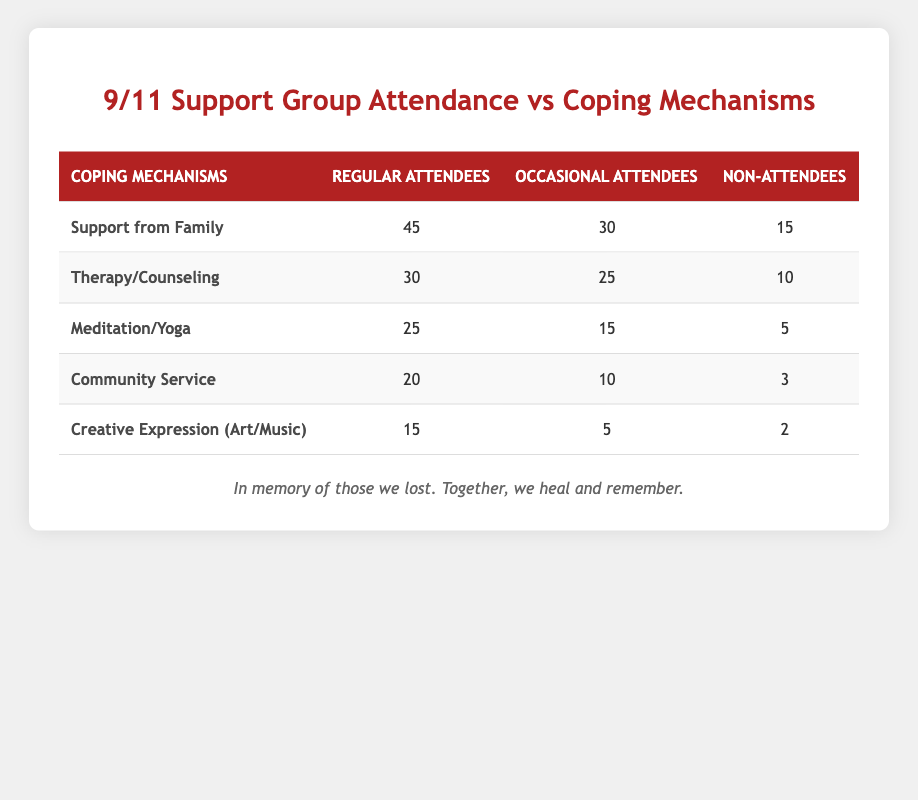What coping mechanism has the highest usage among regular attendees? Looking at the column for "Regular Attendees," the highest number of responses is for "Support from Family," with a value of 45.
Answer: Support from Family How many individuals use "Therapy/Counseling" as a coping mechanism among non-attendees? In the "Non-Attendees" column, under "Therapy/Counseling," the value is 10.
Answer: 10 What is the total number of individuals who utilize "Community Service" as a coping mechanism across all groups? To find the total, I can sum the values from all groups: 20 (Regular Attendees) + 10 (Occasional Attendees) + 3 (Non-Attendees) = 33.
Answer: 33 Is "Meditation/Yoga" used more frequently by occasional attendees than by non-attendees? In the table, the value for "Meditation/Yoga" is 15 for Occasional Attendees and 5 for Non-Attendees, which confirms that it is indeed used more frequently by occasional attendees.
Answer: Yes What is the average usage of "Creative Expression (Art/Music)" across the three attendance categories? To find the average, I need to sum the values 15 (Regular Attendees) + 5 (Occasional Attendees) + 2 (Non-Attendees) = 22. Then I divide by the number of categories, which is 3: 22/3 = approximately 7.33.
Answer: 7.33 